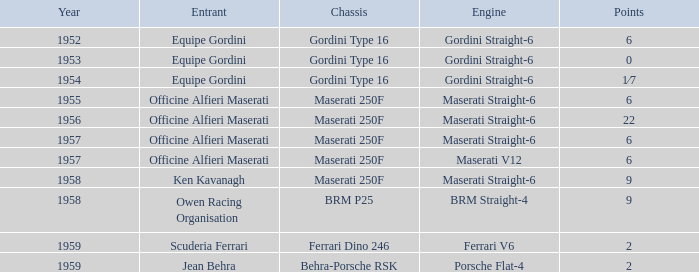Can you parse all the data within this table? {'header': ['Year', 'Entrant', 'Chassis', 'Engine', 'Points'], 'rows': [['1952', 'Equipe Gordini', 'Gordini Type 16', 'Gordini Straight-6', '6'], ['1953', 'Equipe Gordini', 'Gordini Type 16', 'Gordini Straight-6', '0'], ['1954', 'Equipe Gordini', 'Gordini Type 16', 'Gordini Straight-6', '1⁄7'], ['1955', 'Officine Alfieri Maserati', 'Maserati 250F', 'Maserati Straight-6', '6'], ['1956', 'Officine Alfieri Maserati', 'Maserati 250F', 'Maserati Straight-6', '22'], ['1957', 'Officine Alfieri Maserati', 'Maserati 250F', 'Maserati Straight-6', '6'], ['1957', 'Officine Alfieri Maserati', 'Maserati 250F', 'Maserati V12', '6'], ['1958', 'Ken Kavanagh', 'Maserati 250F', 'Maserati Straight-6', '9'], ['1958', 'Owen Racing Organisation', 'BRM P25', 'BRM Straight-4', '9'], ['1959', 'Scuderia Ferrari', 'Ferrari Dino 246', 'Ferrari V6', '2'], ['1959', 'Jean Behra', 'Behra-Porsche RSK', 'Porsche Flat-4', '2']]} What is the entrant of a chassis maserati 250f, also has 6 points and older than year 1957? Officine Alfieri Maserati. 